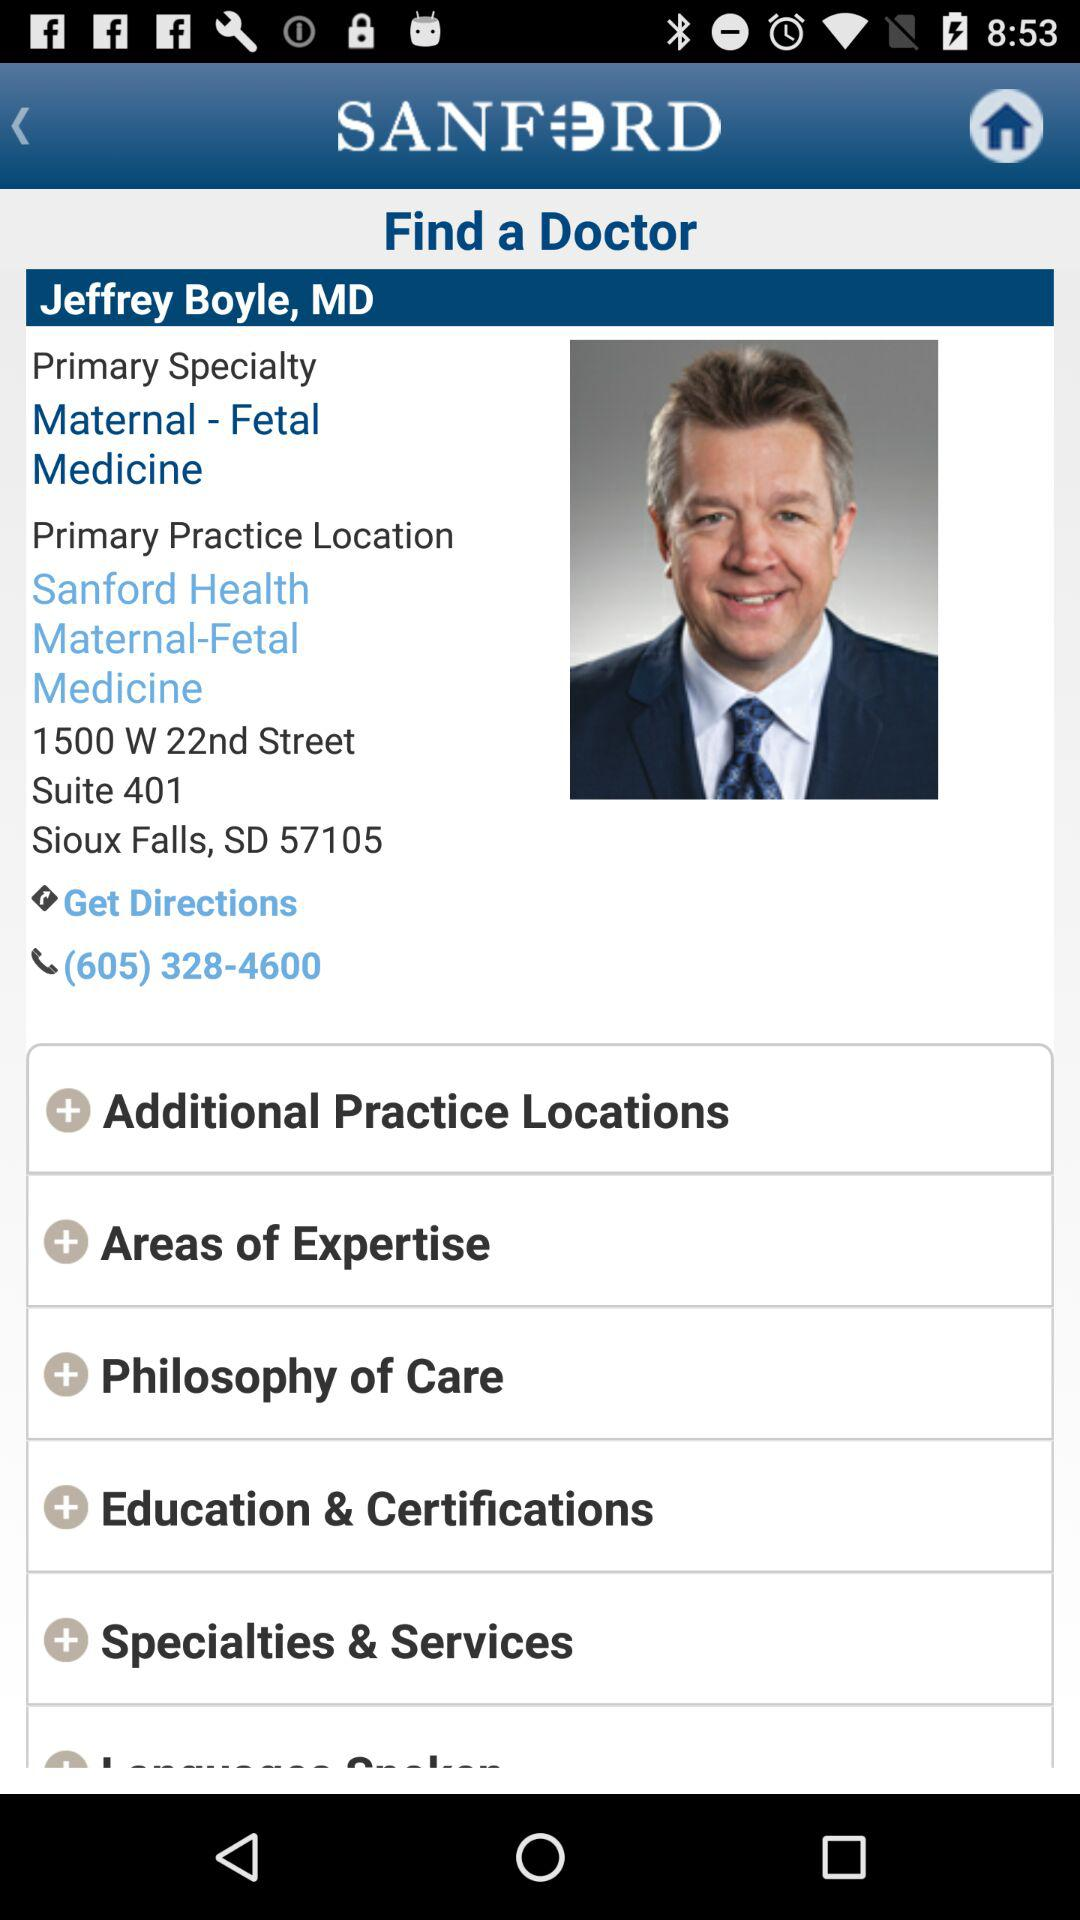What is the given location? The given location is 1500 W. 22nd Street, Suite 401, Sioux Falls, SD 57105. 